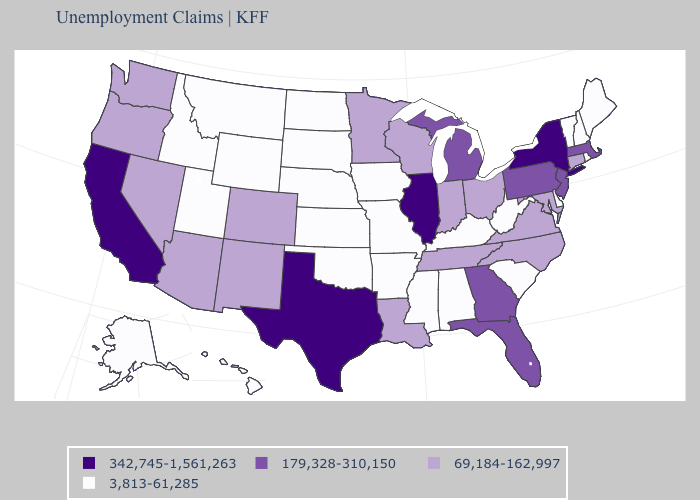Name the states that have a value in the range 69,184-162,997?
Write a very short answer. Arizona, Colorado, Connecticut, Indiana, Louisiana, Maryland, Minnesota, Nevada, New Mexico, North Carolina, Ohio, Oregon, Tennessee, Virginia, Washington, Wisconsin. What is the lowest value in the USA?
Answer briefly. 3,813-61,285. What is the value of New Hampshire?
Write a very short answer. 3,813-61,285. Does Idaho have a lower value than Nevada?
Answer briefly. Yes. What is the highest value in the USA?
Write a very short answer. 342,745-1,561,263. What is the lowest value in states that border Pennsylvania?
Be succinct. 3,813-61,285. Does Utah have a higher value than North Carolina?
Give a very brief answer. No. Does the map have missing data?
Be succinct. No. Name the states that have a value in the range 3,813-61,285?
Write a very short answer. Alabama, Alaska, Arkansas, Delaware, Hawaii, Idaho, Iowa, Kansas, Kentucky, Maine, Mississippi, Missouri, Montana, Nebraska, New Hampshire, North Dakota, Oklahoma, Rhode Island, South Carolina, South Dakota, Utah, Vermont, West Virginia, Wyoming. Name the states that have a value in the range 69,184-162,997?
Answer briefly. Arizona, Colorado, Connecticut, Indiana, Louisiana, Maryland, Minnesota, Nevada, New Mexico, North Carolina, Ohio, Oregon, Tennessee, Virginia, Washington, Wisconsin. Which states hav the highest value in the Northeast?
Write a very short answer. New York. Name the states that have a value in the range 3,813-61,285?
Short answer required. Alabama, Alaska, Arkansas, Delaware, Hawaii, Idaho, Iowa, Kansas, Kentucky, Maine, Mississippi, Missouri, Montana, Nebraska, New Hampshire, North Dakota, Oklahoma, Rhode Island, South Carolina, South Dakota, Utah, Vermont, West Virginia, Wyoming. Among the states that border California , which have the lowest value?
Write a very short answer. Arizona, Nevada, Oregon. 